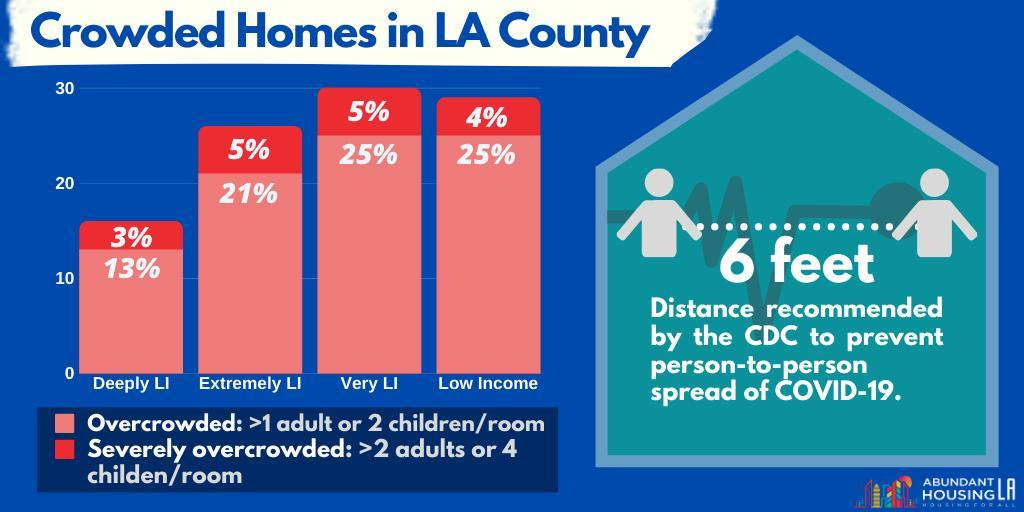What percentage of the overcrowded households in LA county are earning a very low income?
Answer the question with a short phrase. 25% What percentage of the severely overcrowded households in LA county are earning low income? 4% What percentage of the overcrowded households in LA county belongs to the deeply low income group? 13% What percentage of the overcrowded households in LA county are earning an extremely low income? 21% What percentage of the severely overcrowded households in LA county are earning an extremely low income? 5% 